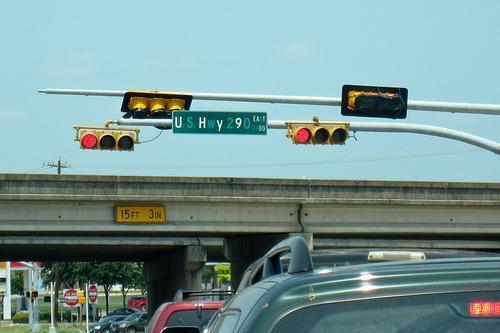How many traffic lights are there?
Give a very brief answer. 4. 